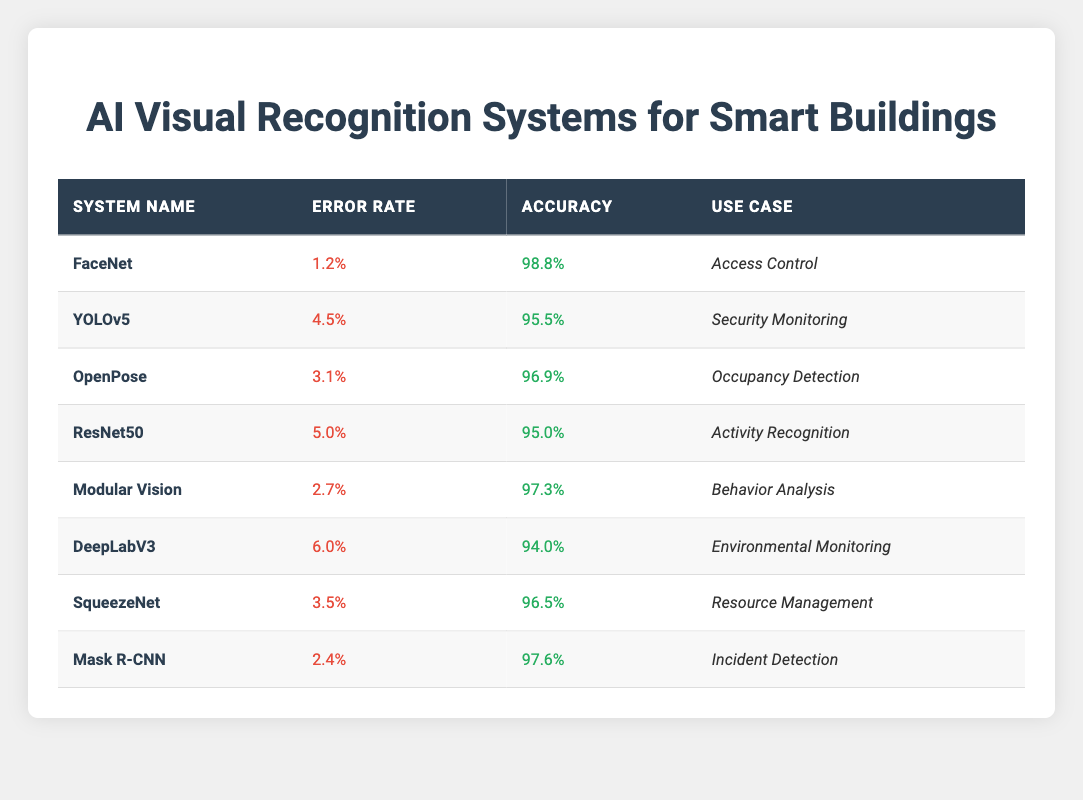What is the error rate of FaceNet? The table lists the error rates for various AI visual recognition systems. For FaceNet, the specified error rate is found in the corresponding row under the "Error Rate" column.
Answer: 1.2% Which system has the highest accuracy? To find the highest accuracy, I compare the "Accuracy" values in each row of the table. The maximum value identified is 98.8% for FaceNet.
Answer: FaceNet What is the average error rate of the listed systems? First, I sum the error rates: 1.2% + 4.5% + 3.1% + 5.0% + 2.7% + 6.0% + 3.5% + 2.4% = 28.4%. There are 8 systems, so the average error rate is 28.4% / 8 = 3.55%.
Answer: 3.55% Is the accuracy of YOLOv5 greater than 90%? The accuracy for YOLOv5, according to the table, is 95.5%. Since 95.5% is greater than 90%, the statement is true.
Answer: Yes Which system is used for incident detection and what is its error rate? The table indicates the use case for each system. Looking for "Incident Detection," I find that Mask R-CNN is associated with this use case and has an error rate of 2.4%.
Answer: Mask R-CNN, 2.4% What is the error rate for the system with the highest error? By examining the error rates listed, the highest error rate is identified from the "Error Rate" column, which is 6.0% from DeepLabV3.
Answer: 6.0% If we combine the accuracy of Modular Vision and Mask R-CNN, what is their total accuracy? The accuracy for Modular Vision is 97.3%, and for Mask R-CNN, it is 97.6%. Adding these together gives a total: 97.3% + 97.6% = 194.9%.
Answer: 194.9% Are any systems designed for security monitoring? I check the "Use Case" column for any mention of "Security Monitoring" and find that YOLOv5 is listed for this purpose.
Answer: Yes What is the difference in accuracy between DeepLabV3 and SqueezeNet? The accuracy of DeepLabV3 is 94.0%, and SqueezeNet is 96.5%. The difference in their accuracies is calculated as 96.5% - 94.0% = 2.5%.
Answer: 2.5% Which use case has the lowest error rate and which system is associated with it? Reviewing the "Error Rate" column and identifying the lowest value, which is 1.2% associated with FaceNet for Access Control use case.
Answer: Access Control, FaceNet 